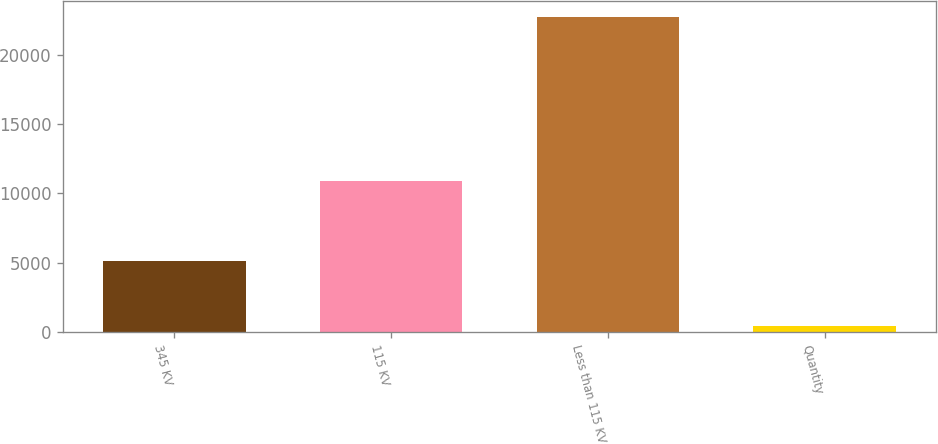Convert chart to OTSL. <chart><loc_0><loc_0><loc_500><loc_500><bar_chart><fcel>345 KV<fcel>115 KV<fcel>Less than 115 KV<fcel>Quantity<nl><fcel>5139<fcel>10878<fcel>22724<fcel>432<nl></chart> 